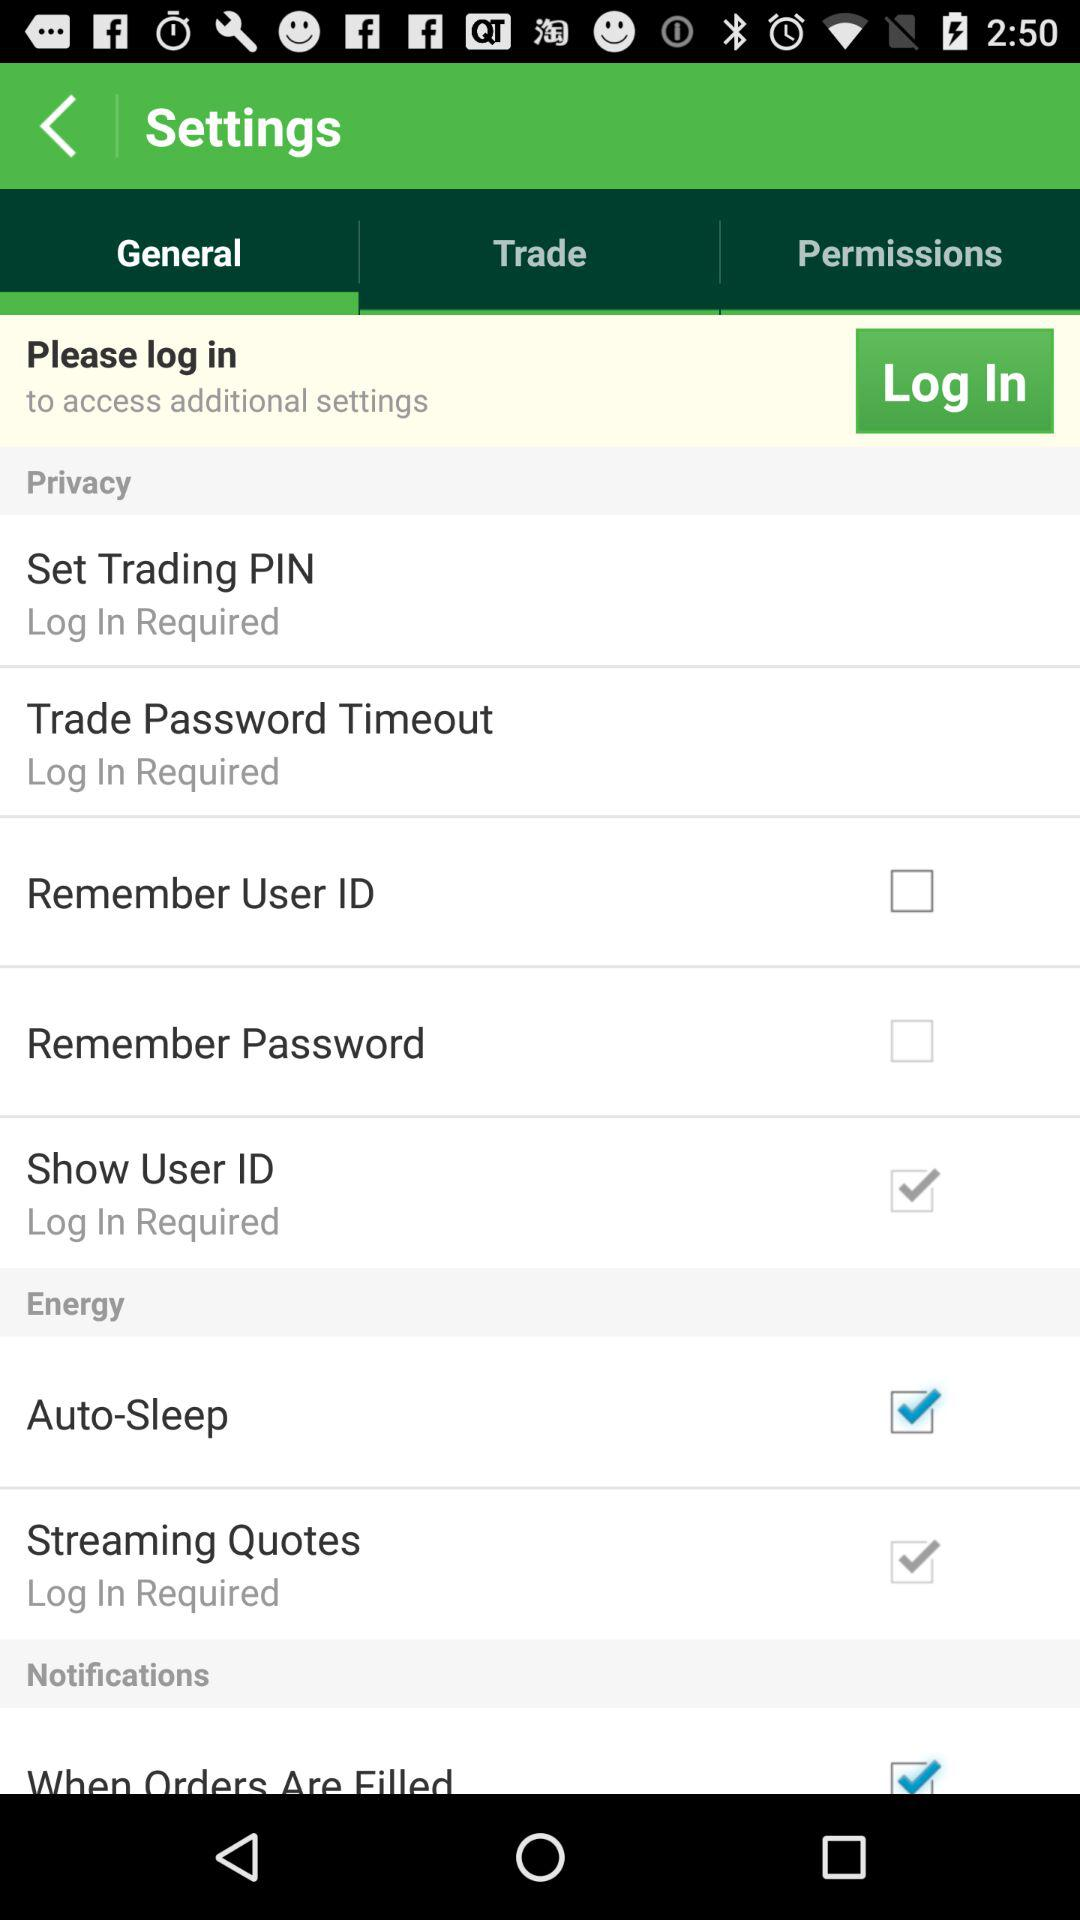What's the status of the "Auto-Sleep"? The status is "on". 